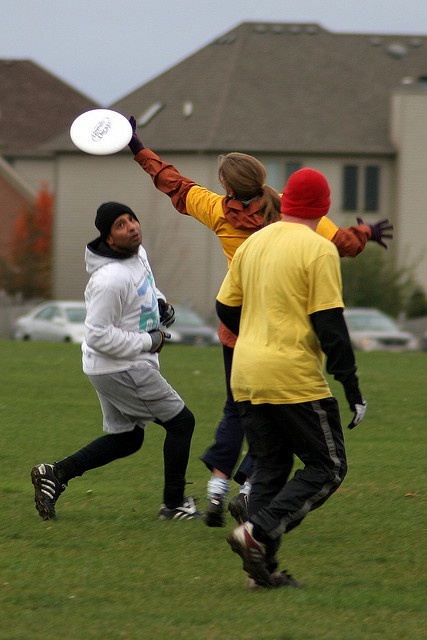Describe the objects in this image and their specific colors. I can see people in lightgray, black, tan, olive, and khaki tones, people in lightgray, black, gray, and darkgray tones, people in lightgray, black, maroon, olive, and brown tones, car in lightgray, darkgray, and gray tones, and car in lightgray, darkgray, gray, and darkgreen tones in this image. 